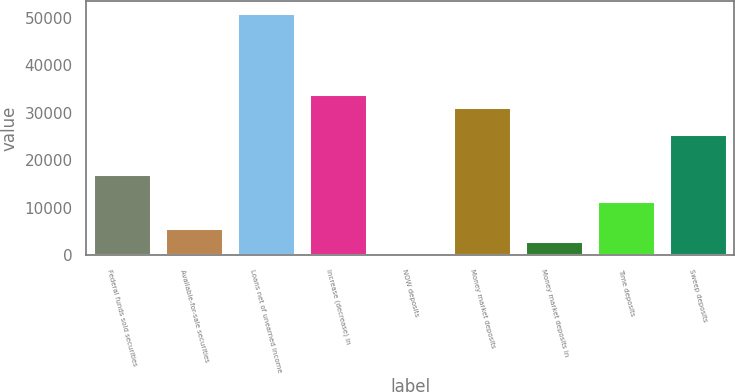Convert chart to OTSL. <chart><loc_0><loc_0><loc_500><loc_500><bar_chart><fcel>Federal funds sold securities<fcel>Available-for-sale securities<fcel>Loans net of unearned income<fcel>Increase (decrease) in<fcel>NOW deposits<fcel>Money market deposits<fcel>Money market deposits in<fcel>Time deposits<fcel>Sweep deposits<nl><fcel>17060.8<fcel>5735.6<fcel>51036.4<fcel>34048.6<fcel>73<fcel>31217.3<fcel>2904.3<fcel>11398.2<fcel>25554.7<nl></chart> 